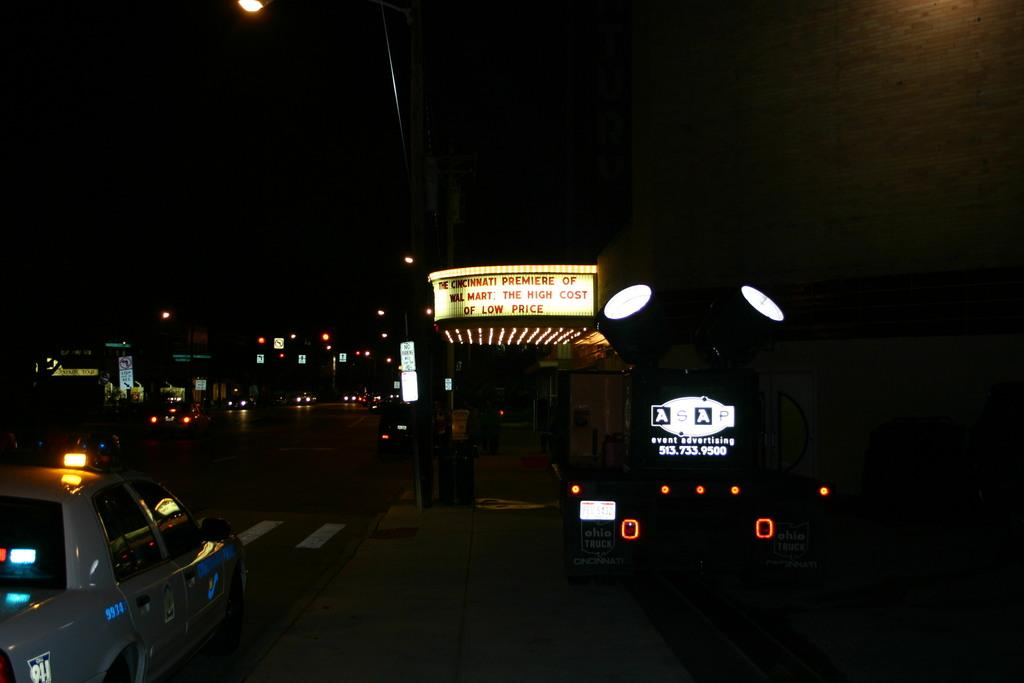What can be seen in the left corner of the image? There are vehicles on the road in the left corner of the image. What is located in the right corner of the image? There is a building in the right corner of the image. What feature does the building have? The building has lights. What is written on the building? There is something written on the building. What type of stitch is being used to repair the sidewalk in the image? There is no sidewalk or stitching present in the image. Where is the place mentioned in the image? There is no specific place mentioned in the image. 